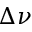Convert formula to latex. <formula><loc_0><loc_0><loc_500><loc_500>\Delta \nu</formula> 